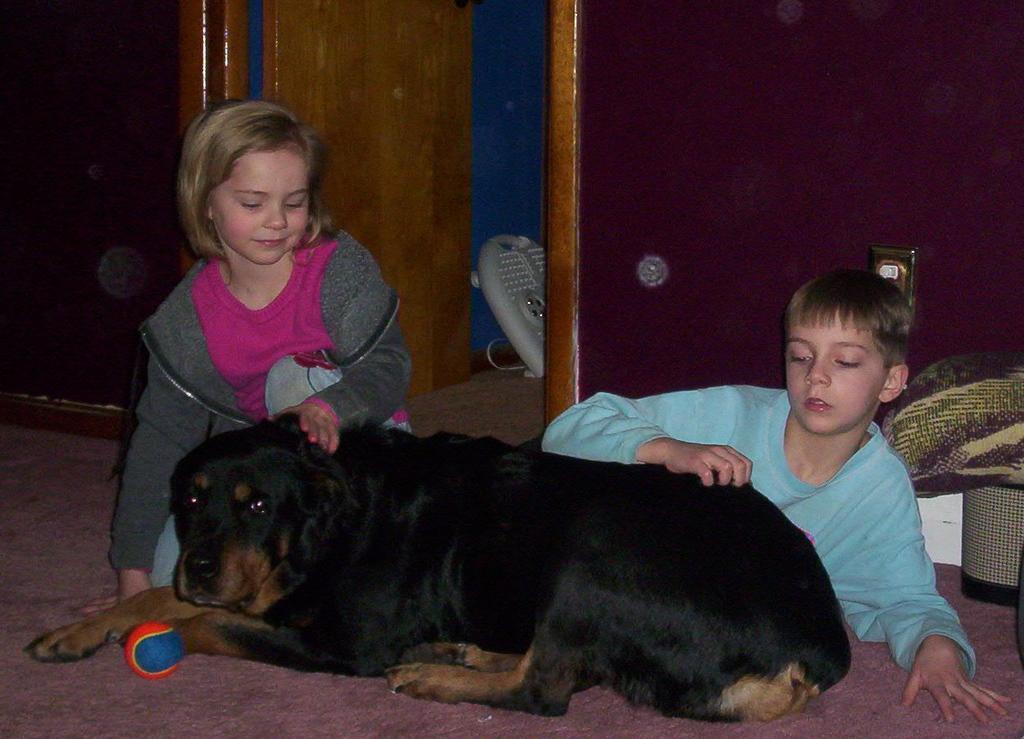Describe this image in one or two sentences. As we can see in the image there is a black color dog, ball, two people sitting over here, wall and door. 